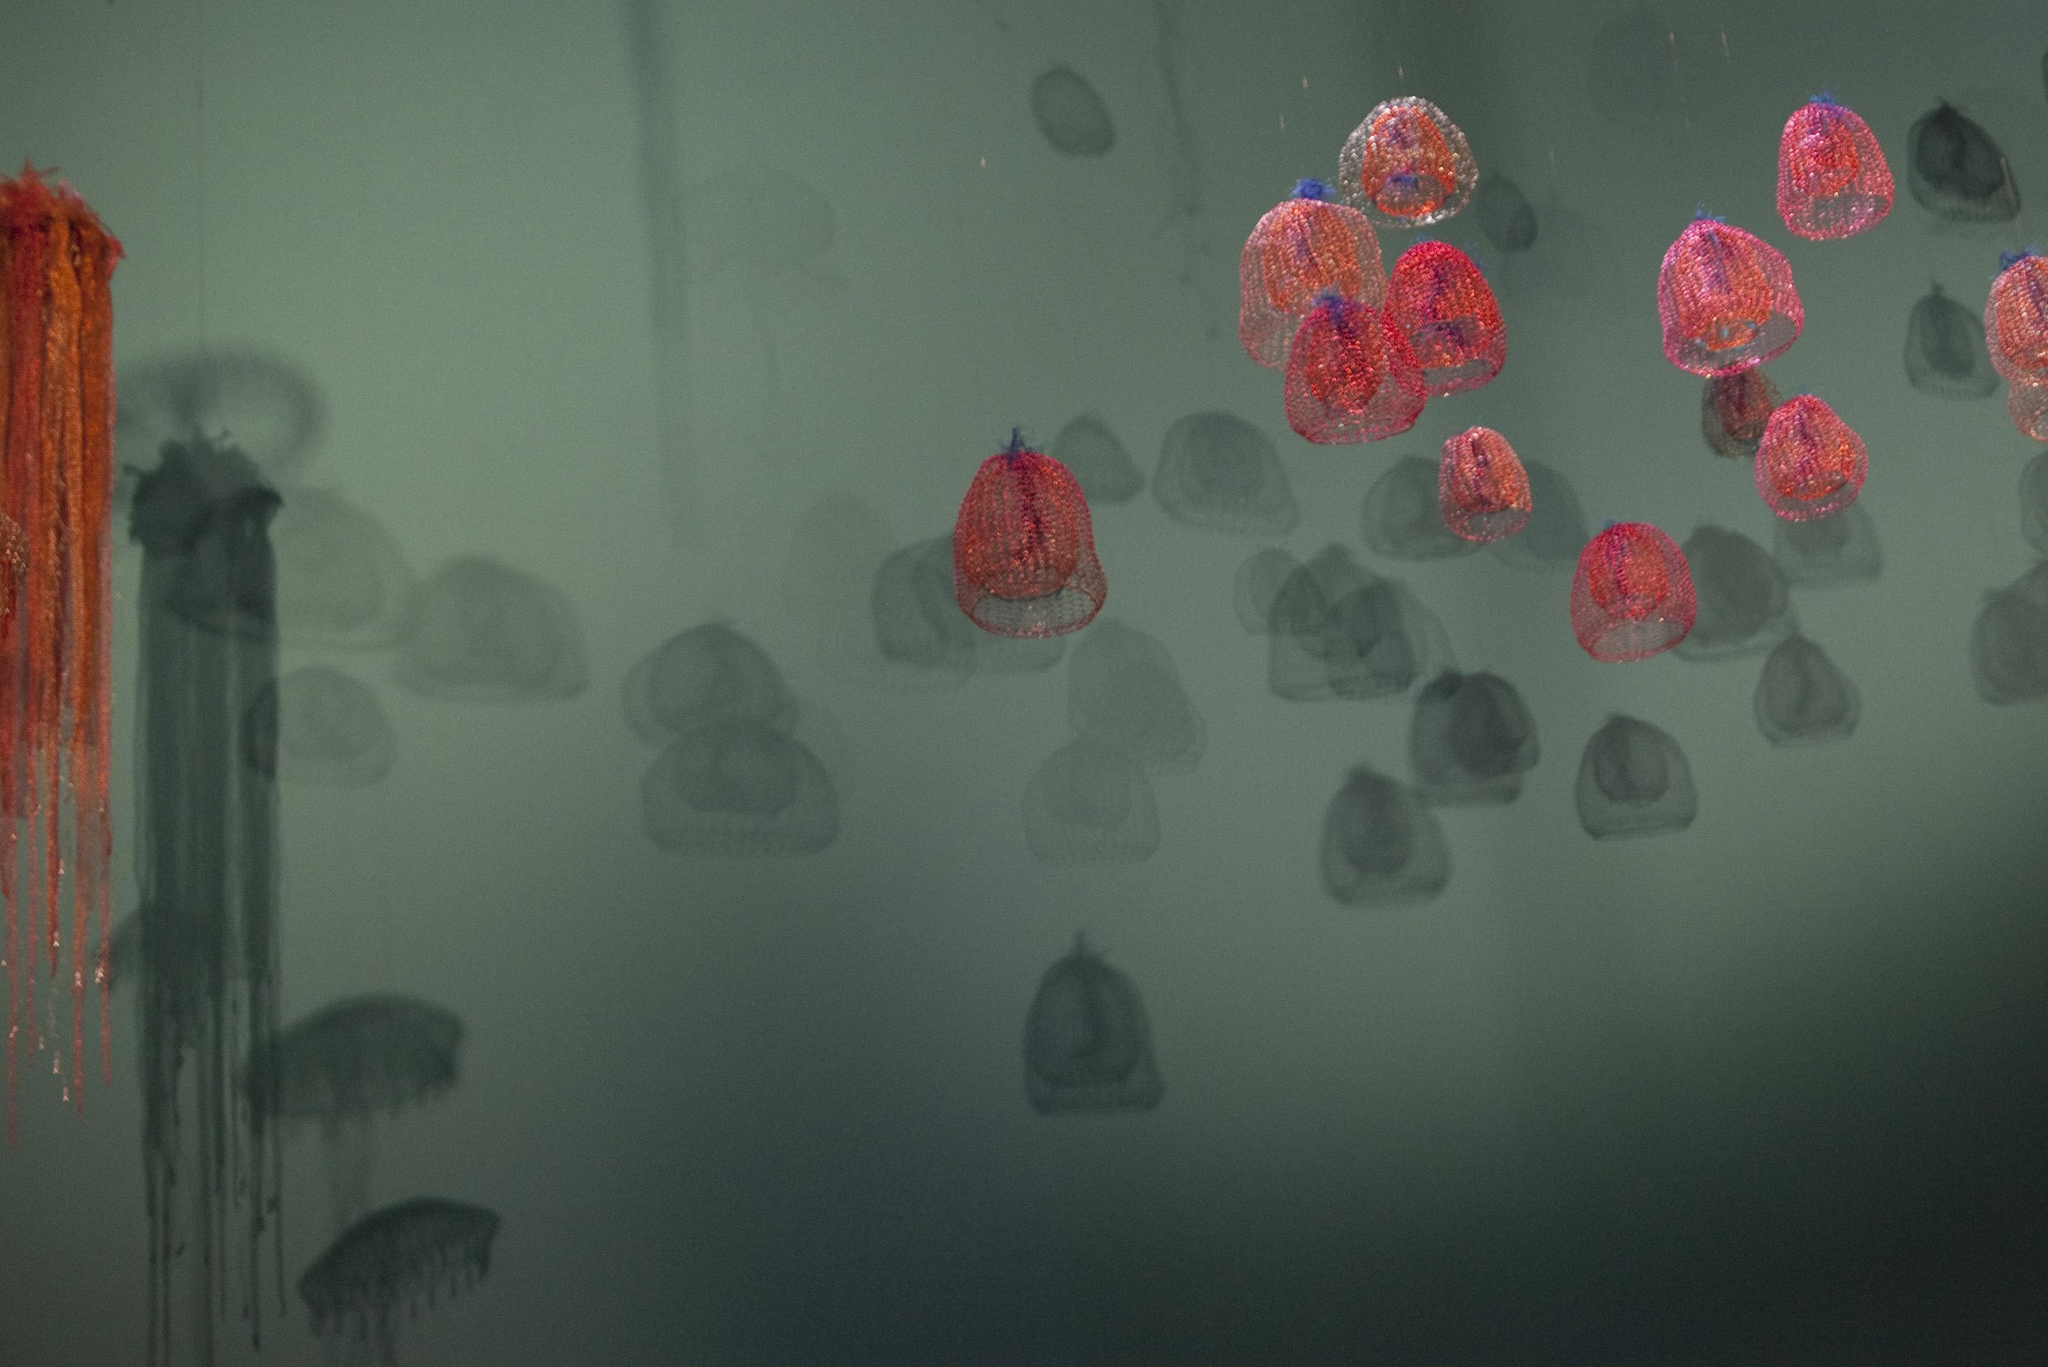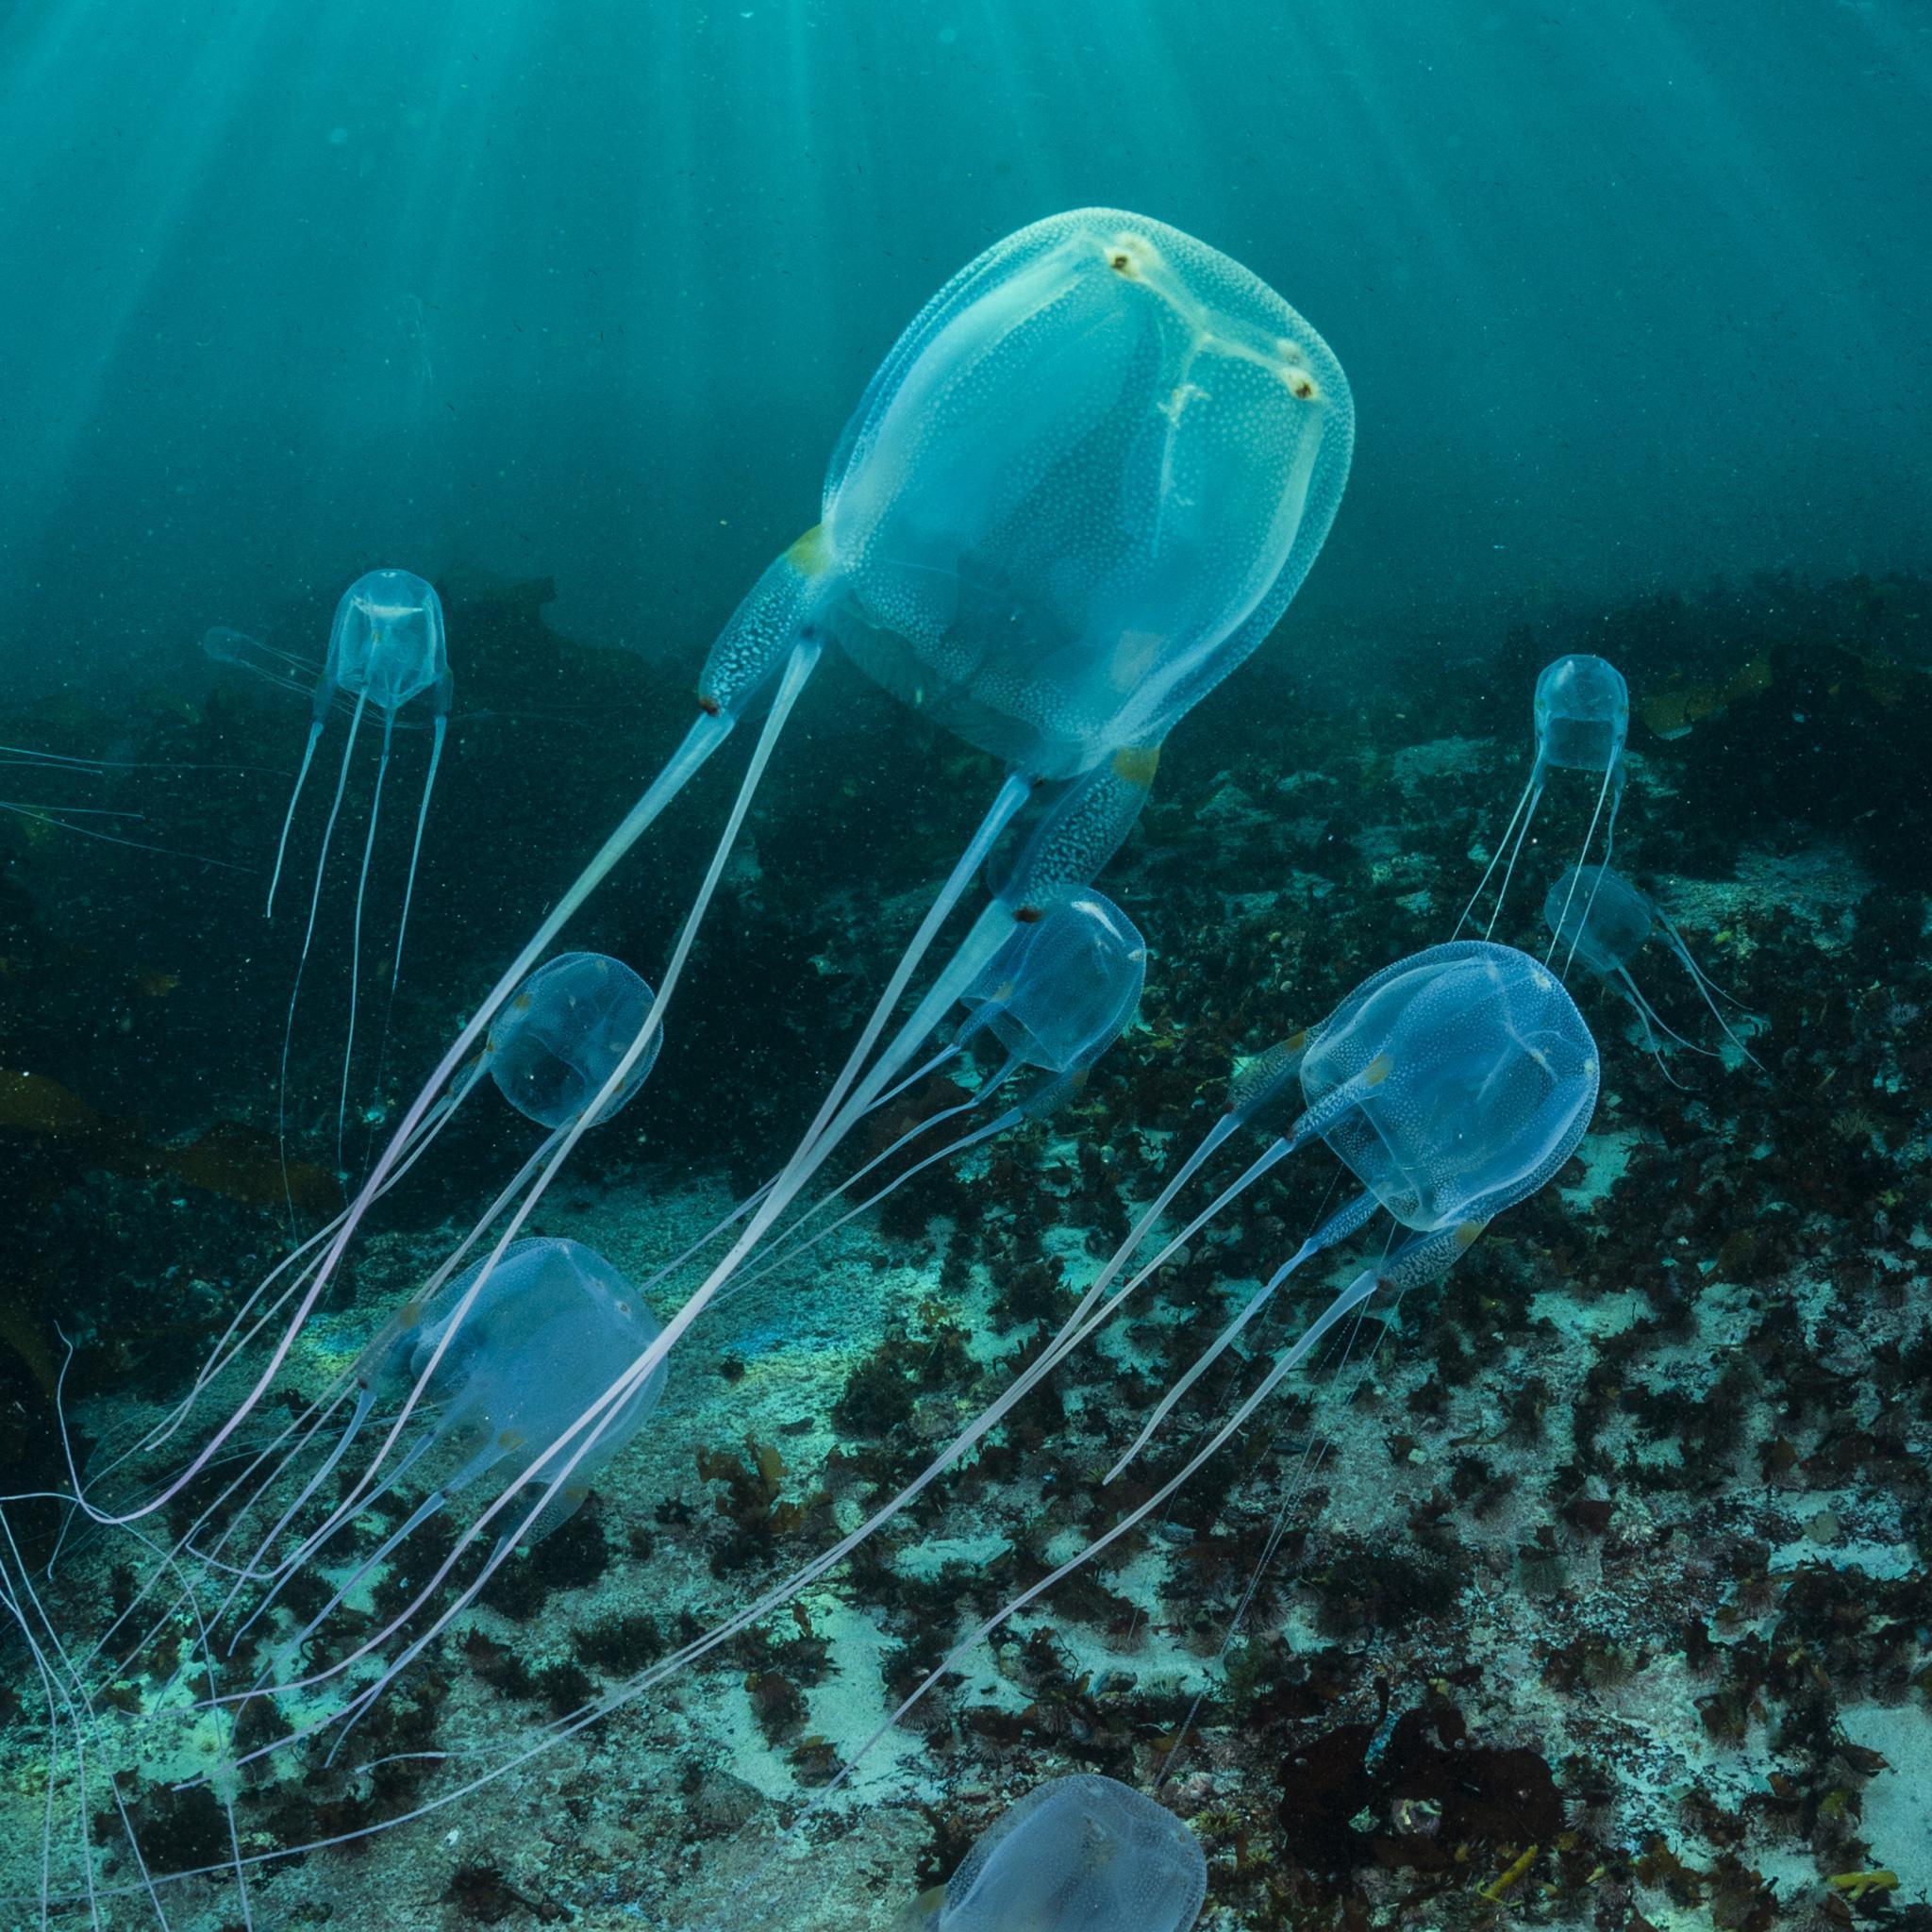The first image is the image on the left, the second image is the image on the right. Evaluate the accuracy of this statement regarding the images: "Neon pink jellyfish are shown in the right image.". Is it true? Answer yes or no. No. The first image is the image on the left, the second image is the image on the right. Analyze the images presented: Is the assertion "At least one jellyfish has tentacles longer than its body." valid? Answer yes or no. Yes. 